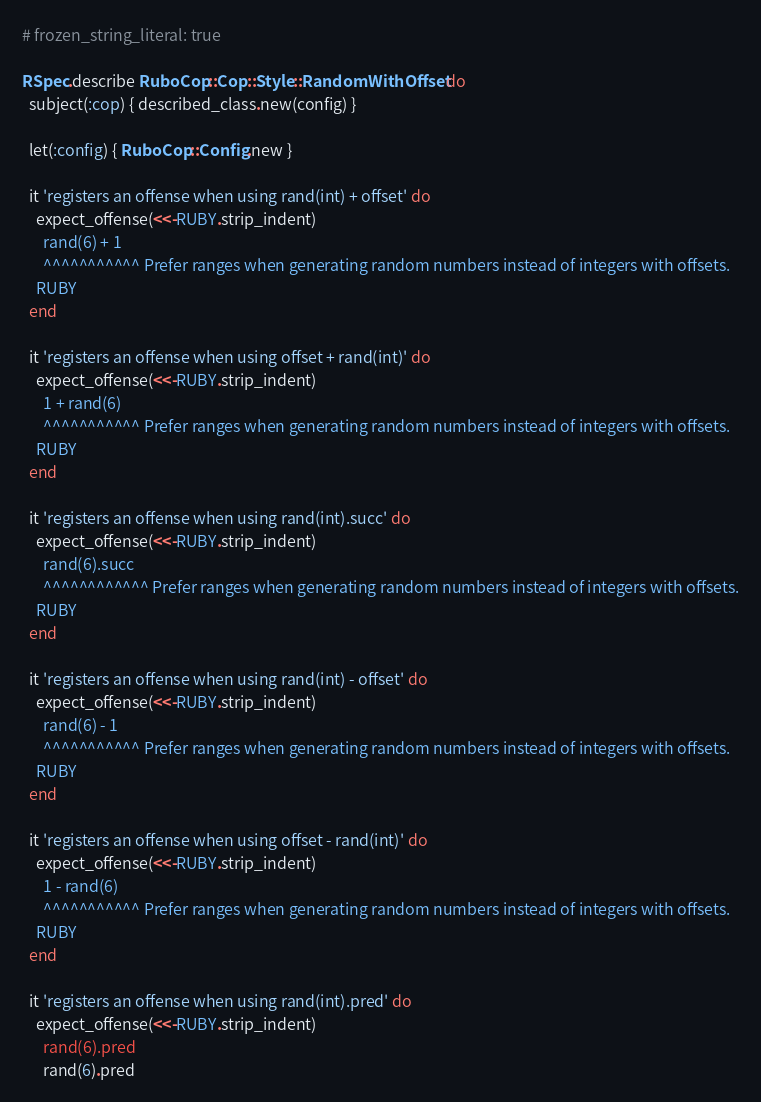Convert code to text. <code><loc_0><loc_0><loc_500><loc_500><_Ruby_># frozen_string_literal: true

RSpec.describe RuboCop::Cop::Style::RandomWithOffset do
  subject(:cop) { described_class.new(config) }

  let(:config) { RuboCop::Config.new }

  it 'registers an offense when using rand(int) + offset' do
    expect_offense(<<-RUBY.strip_indent)
      rand(6) + 1
      ^^^^^^^^^^^ Prefer ranges when generating random numbers instead of integers with offsets.
    RUBY
  end

  it 'registers an offense when using offset + rand(int)' do
    expect_offense(<<-RUBY.strip_indent)
      1 + rand(6)
      ^^^^^^^^^^^ Prefer ranges when generating random numbers instead of integers with offsets.
    RUBY
  end

  it 'registers an offense when using rand(int).succ' do
    expect_offense(<<-RUBY.strip_indent)
      rand(6).succ
      ^^^^^^^^^^^^ Prefer ranges when generating random numbers instead of integers with offsets.
    RUBY
  end

  it 'registers an offense when using rand(int) - offset' do
    expect_offense(<<-RUBY.strip_indent)
      rand(6) - 1
      ^^^^^^^^^^^ Prefer ranges when generating random numbers instead of integers with offsets.
    RUBY
  end

  it 'registers an offense when using offset - rand(int)' do
    expect_offense(<<-RUBY.strip_indent)
      1 - rand(6)
      ^^^^^^^^^^^ Prefer ranges when generating random numbers instead of integers with offsets.
    RUBY
  end

  it 'registers an offense when using rand(int).pred' do
    expect_offense(<<-RUBY.strip_indent)
      rand(6).pred</code> 